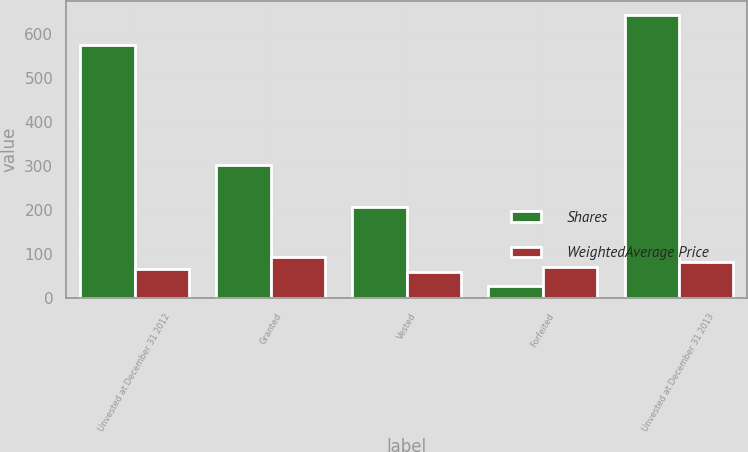Convert chart to OTSL. <chart><loc_0><loc_0><loc_500><loc_500><stacked_bar_chart><ecel><fcel>Unvested at December 31 2012<fcel>Granted<fcel>Vested<fcel>Forfeited<fcel>Unvested at December 31 2013<nl><fcel>Shares<fcel>574<fcel>303<fcel>207<fcel>28<fcel>642<nl><fcel>WeightedAverage Price<fcel>67.28<fcel>94.74<fcel>60.65<fcel>72.27<fcel>82.16<nl></chart> 